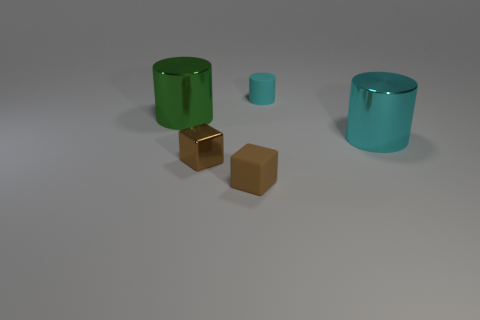Subtract all green cylinders. How many cylinders are left? 2 Subtract 1 blocks. How many blocks are left? 1 Add 4 brown matte blocks. How many objects exist? 9 Subtract all cubes. How many objects are left? 3 Subtract all red cylinders. Subtract all green cubes. How many cylinders are left? 3 Subtract all gray blocks. How many yellow cylinders are left? 0 Subtract all brown things. Subtract all green cylinders. How many objects are left? 2 Add 4 brown things. How many brown things are left? 6 Add 1 tiny gray metal blocks. How many tiny gray metal blocks exist? 1 Subtract all cyan cylinders. How many cylinders are left? 1 